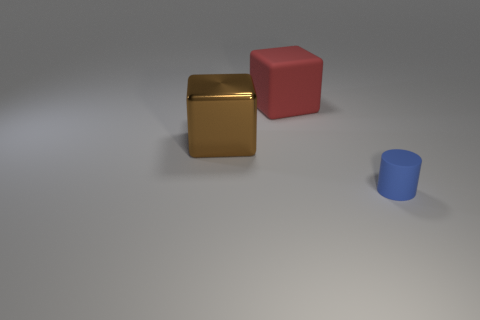Is there a sense of depth in this image? Yes, there's a sense of depth created by the perspective of the objects — the smallest blue cylinder appears closer due to its size and the shadows suggest spatial relationships among the objects.  Based on the shadows, where do you think the light source is located? The light source is likely located above and possibly slightly in front of the objects, given the direction and length of the shadows cast behind and to the right of the objects. 